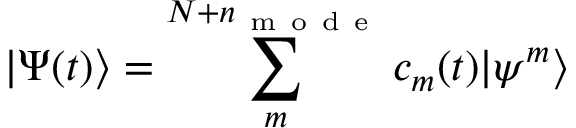<formula> <loc_0><loc_0><loc_500><loc_500>| \Psi ( t ) \rangle = \sum _ { m } ^ { N + n _ { m o d e } } c _ { m } ( t ) | \psi ^ { m } \rangle</formula> 